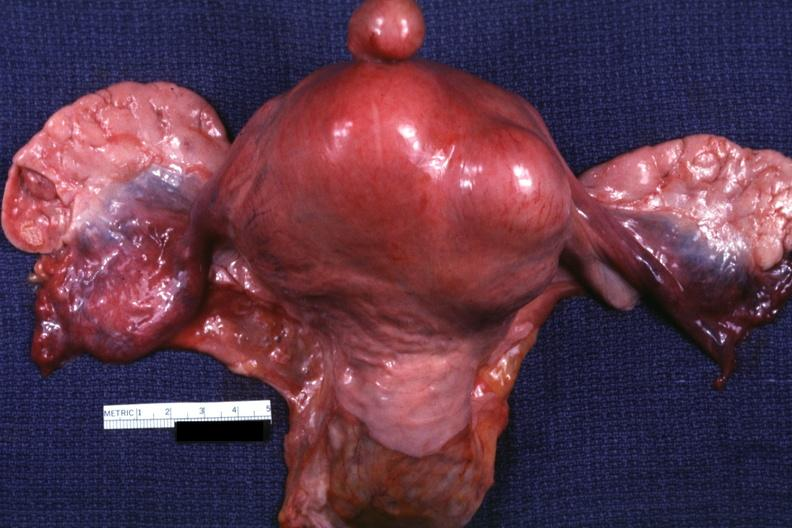what is present?
Answer the question using a single word or phrase. Leiomyoma 